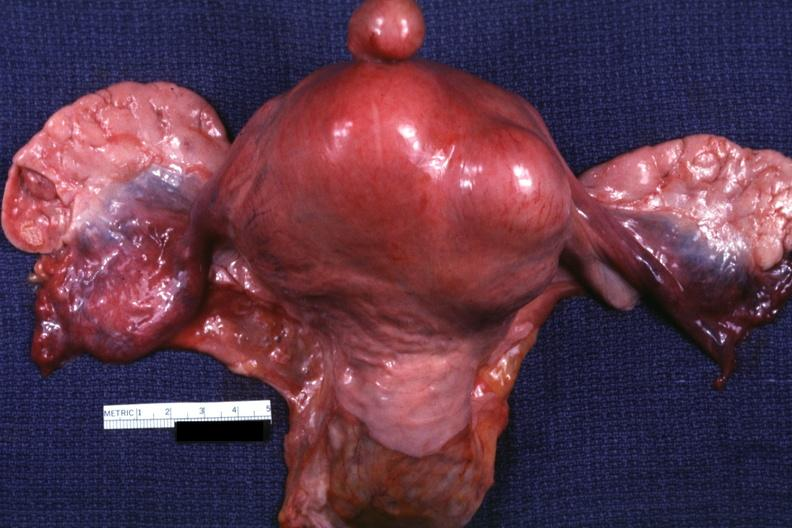what is present?
Answer the question using a single word or phrase. Leiomyoma 